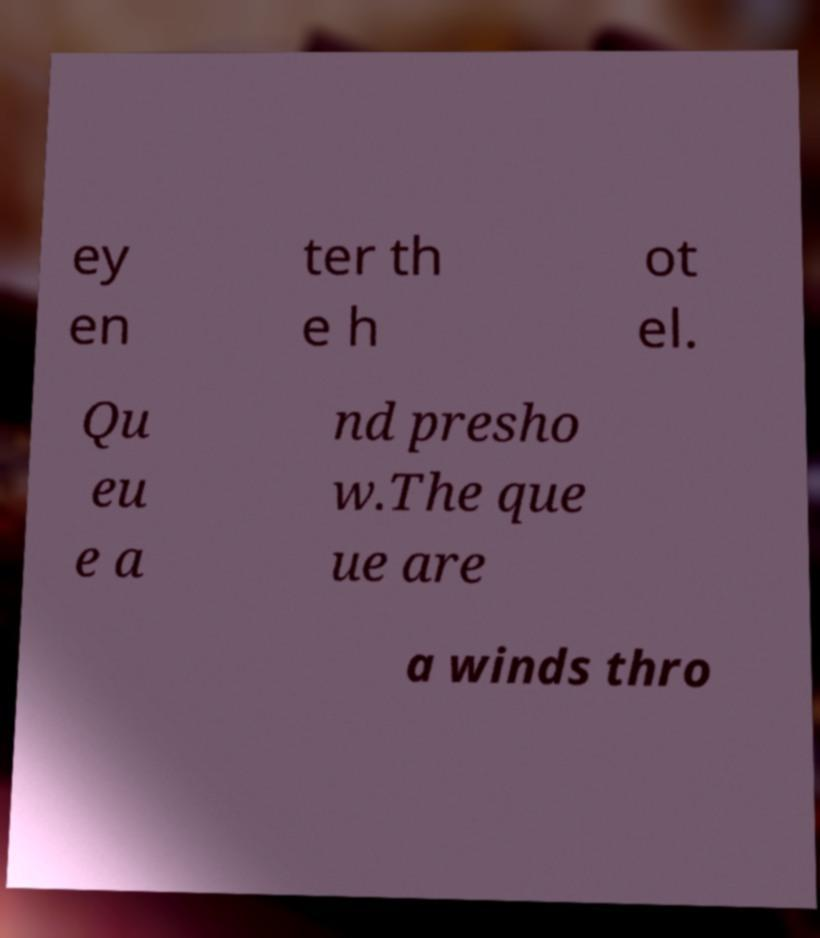I need the written content from this picture converted into text. Can you do that? ey en ter th e h ot el. Qu eu e a nd presho w.The que ue are a winds thro 